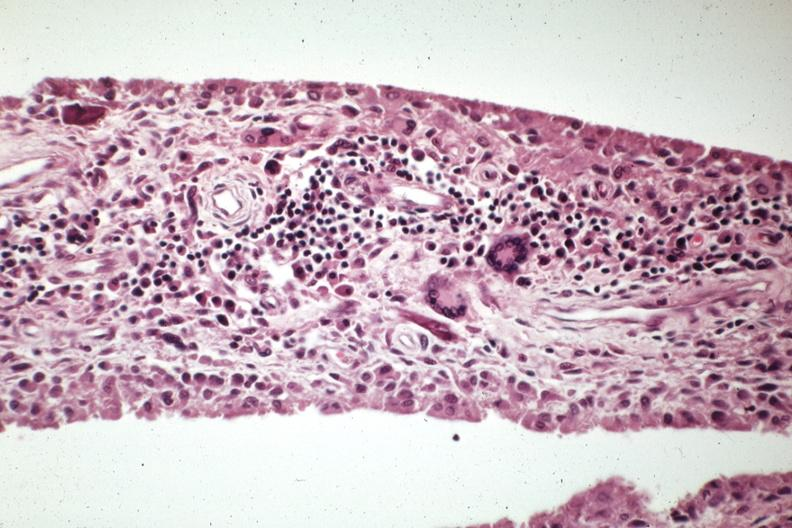what is present?
Answer the question using a single word or phrase. Joints 